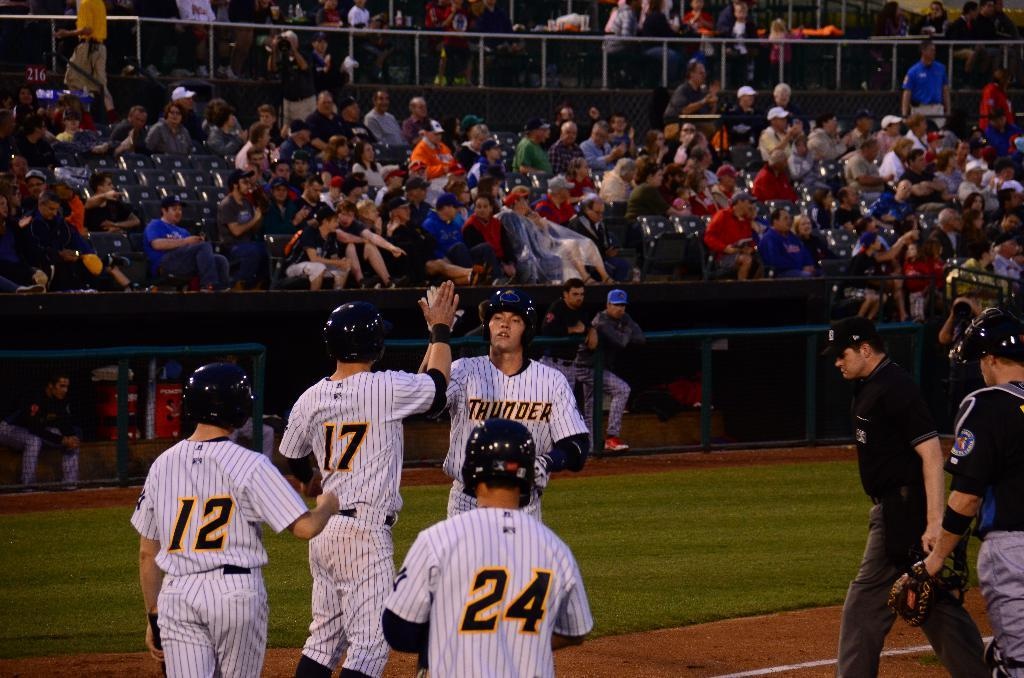<image>
Share a concise interpretation of the image provided. Baseball players wearing a jersey for the team "Thunder". 